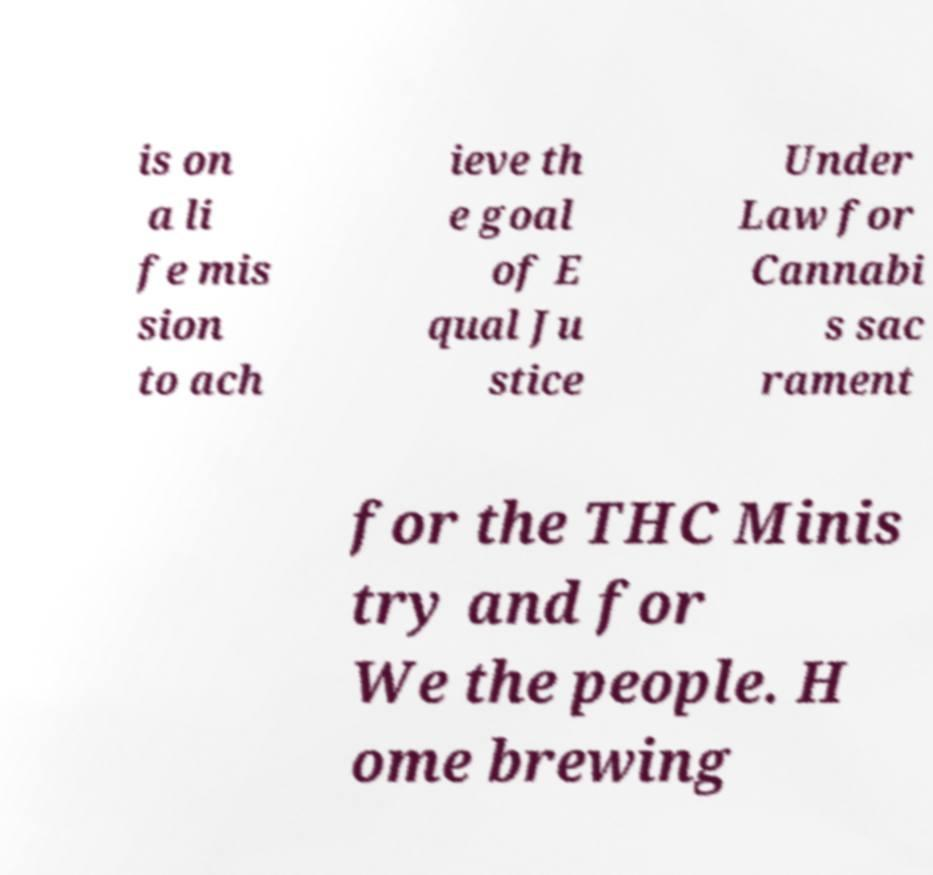Could you extract and type out the text from this image? is on a li fe mis sion to ach ieve th e goal of E qual Ju stice Under Law for Cannabi s sac rament for the THC Minis try and for We the people. H ome brewing 